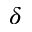Convert formula to latex. <formula><loc_0><loc_0><loc_500><loc_500>\delta</formula> 